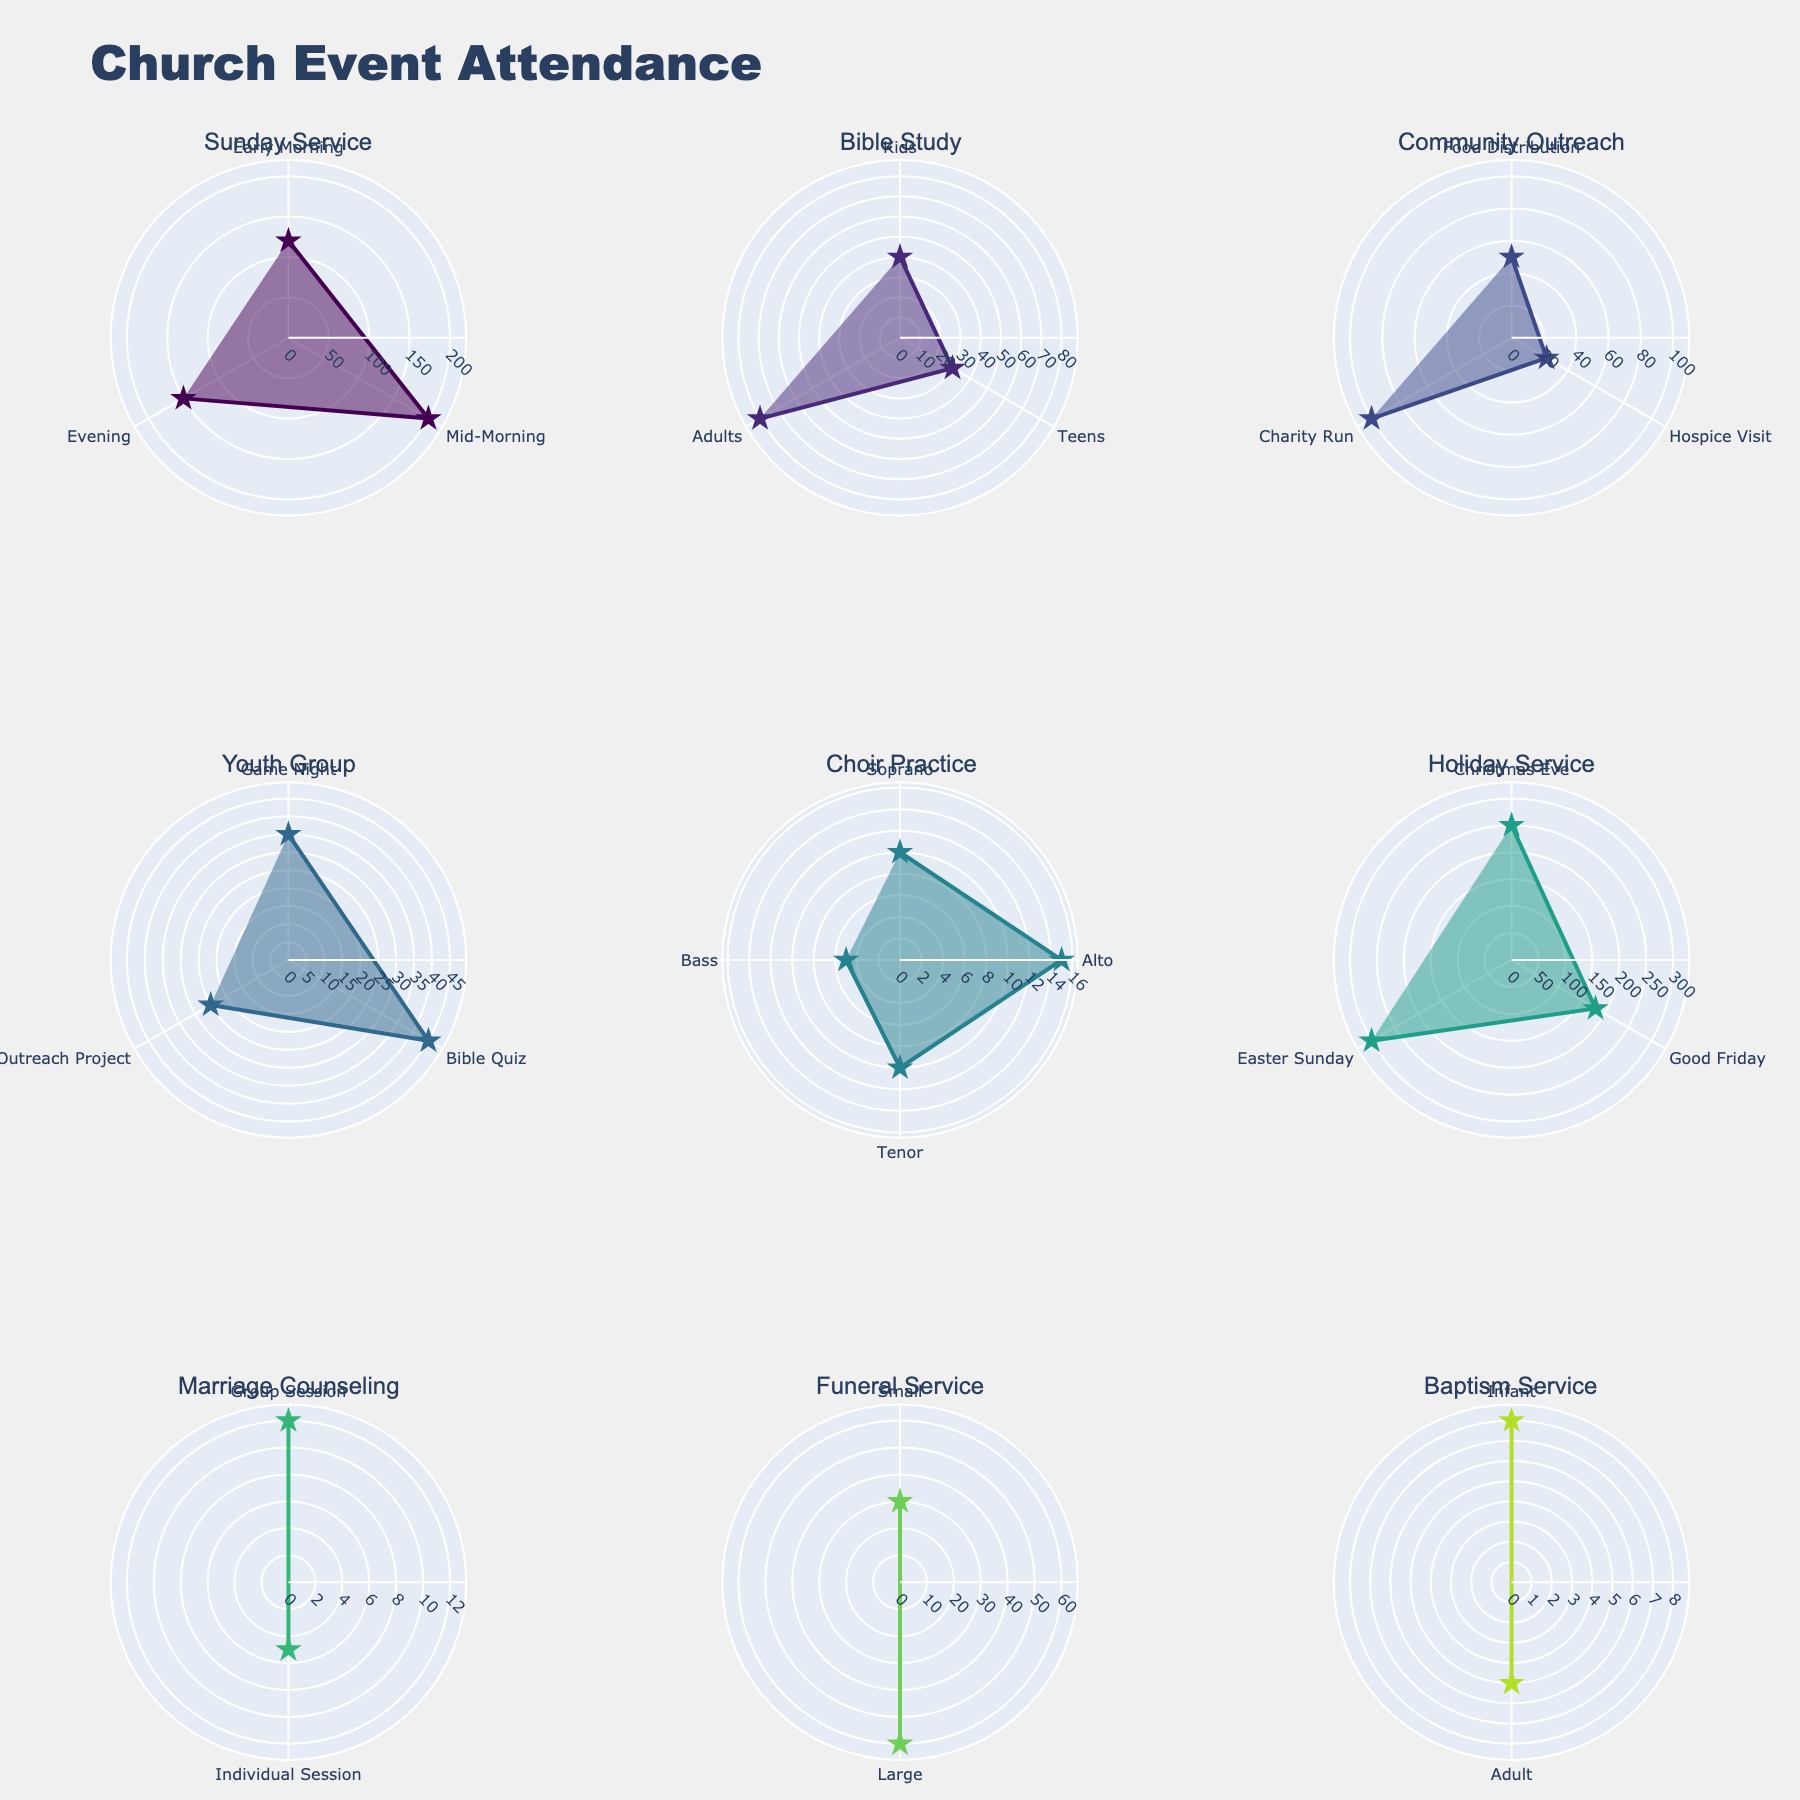What is the highest attendance recorded in any event? The highest attendance can be observed to identify the data point with the maximum radius on any subplot. In this case, it is in the Holiday Service for Easter Sunday.
Answer: 300 What subevent has the lowest attendance in the Youth Group events? Inspect the Youth Group subplot and identify the subevent with the smallest radius. The Outreach Project has the lowest attendance.
Answer: Outreach Project Which event has the highest average attendance? Calculate the average attendance for each event by summing the attendance numbers and dividing by the number of subevents for that event. Holiday Service has three subevents with one being 250, another being 180, and another being 300, making the average (250+180+300)/3 ≈ 243.33, which is the highest.
Answer: Holiday Service Compare the attendance of the Mid-Morning Sunday Service to the total attendance of the Bible Study group. Which is higher? The Mid-Morning Sunday Service has 200 attendees. The total attendance for Bible Study is 40 (Kids) + 30 (Teens) + 80 (Adults) = 150. Therefore, the Mid-Morning Sunday Service attendance is higher.
Answer: Mid-Morning Sunday Service What is the total attendance for all Community Outreach subevents combined? Sum the attendance values for all Community Outreach subevents: 50 (Food Distribution) + 25 (Hospice Visit) + 100 (Charity Run) = 175.
Answer: 175 Which Choir Practice subevent has the highest attendance? Look at the Choir Practice subplot and check the subevent with the largest radius. The Alto subevent has the highest attendance of 15.
Answer: Alto Which event has the smallest variance in attendance across its subevents? First, calculate the variance for each event by determining the average attendance, then the sum of squared differences from the mean, divided by the number of subevents. Choir Practice has attendances of 10 (Soprano), 15 (Alto), 10 (Tenor), and 5 (Bass), mean is (10+15+10+5)/4 = 10. The variance is ((10-10)^2 + (15-10)^2 + (10-10)^2 + (5-10)^2)/4 = (0 + 25 + 0 + 25)/4 = 12.5, which is the smallest.
Answer: Choir Practice How does the attendance of the Early Morning Sunday Service compare to the evening one? The Early Morning Sunday Service has 120 attendees, while the Evening Sunday Service has 150. Hence, the Evening Sunday Service has higher attendance.
Answer: Evening Sunday Service What is the average attendance for Marriage Counseling sessions? Calculate the average attendance of the Marriage Counseling event by summing up and dividing by the number of subevents: (12 + 5)/2 = 8.5.
Answer: 8.5 Which Holiday Service event has the second-highest attendance? Look at the Holiday Service subplot and identify the attendances of the subevents: 250 (Christmas Eve), 180 (Good Friday), 300 (Easter Sunday). The second-highest attendance is for Christmas Eve with 250.
Answer: Christmas Eve 